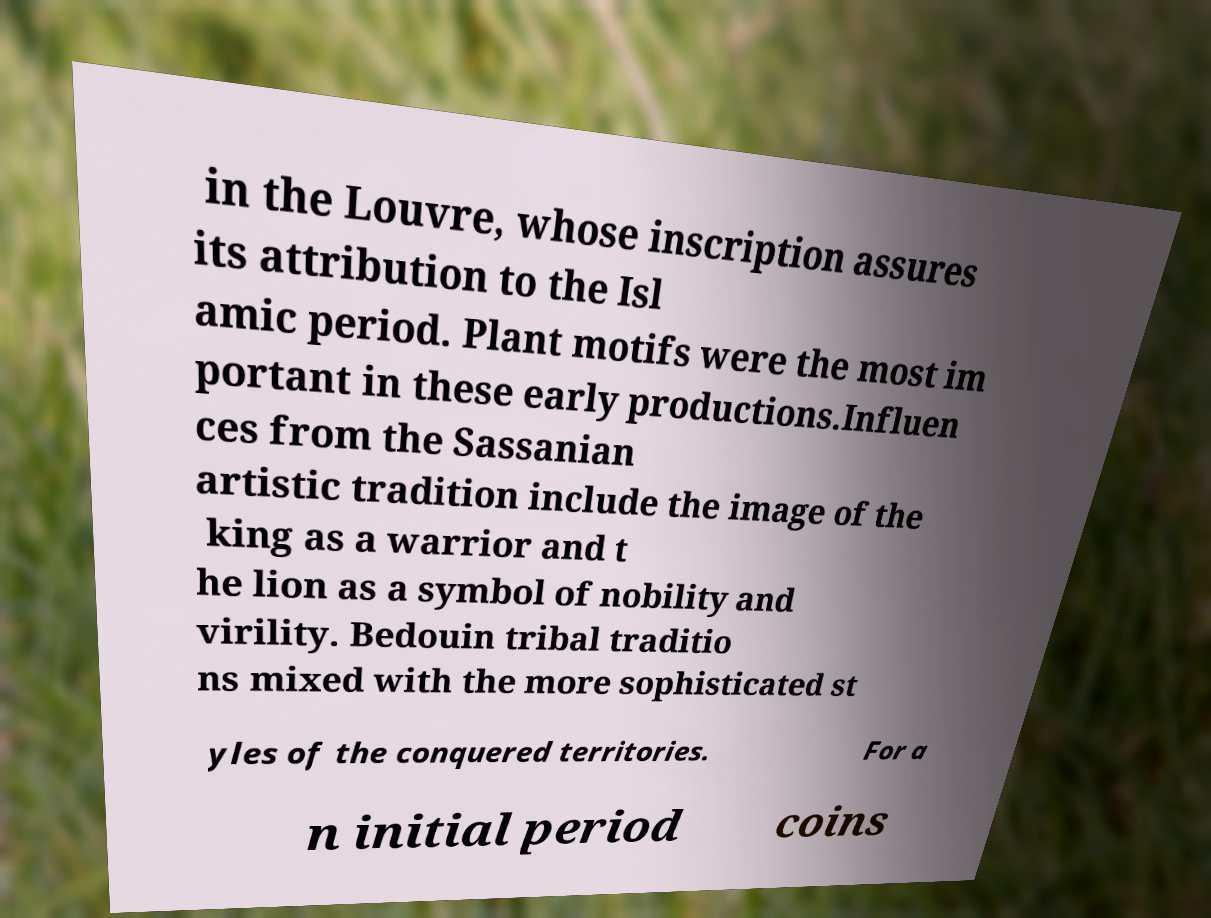Please read and relay the text visible in this image. What does it say? in the Louvre, whose inscription assures its attribution to the Isl amic period. Plant motifs were the most im portant in these early productions.Influen ces from the Sassanian artistic tradition include the image of the king as a warrior and t he lion as a symbol of nobility and virility. Bedouin tribal traditio ns mixed with the more sophisticated st yles of the conquered territories. For a n initial period coins 